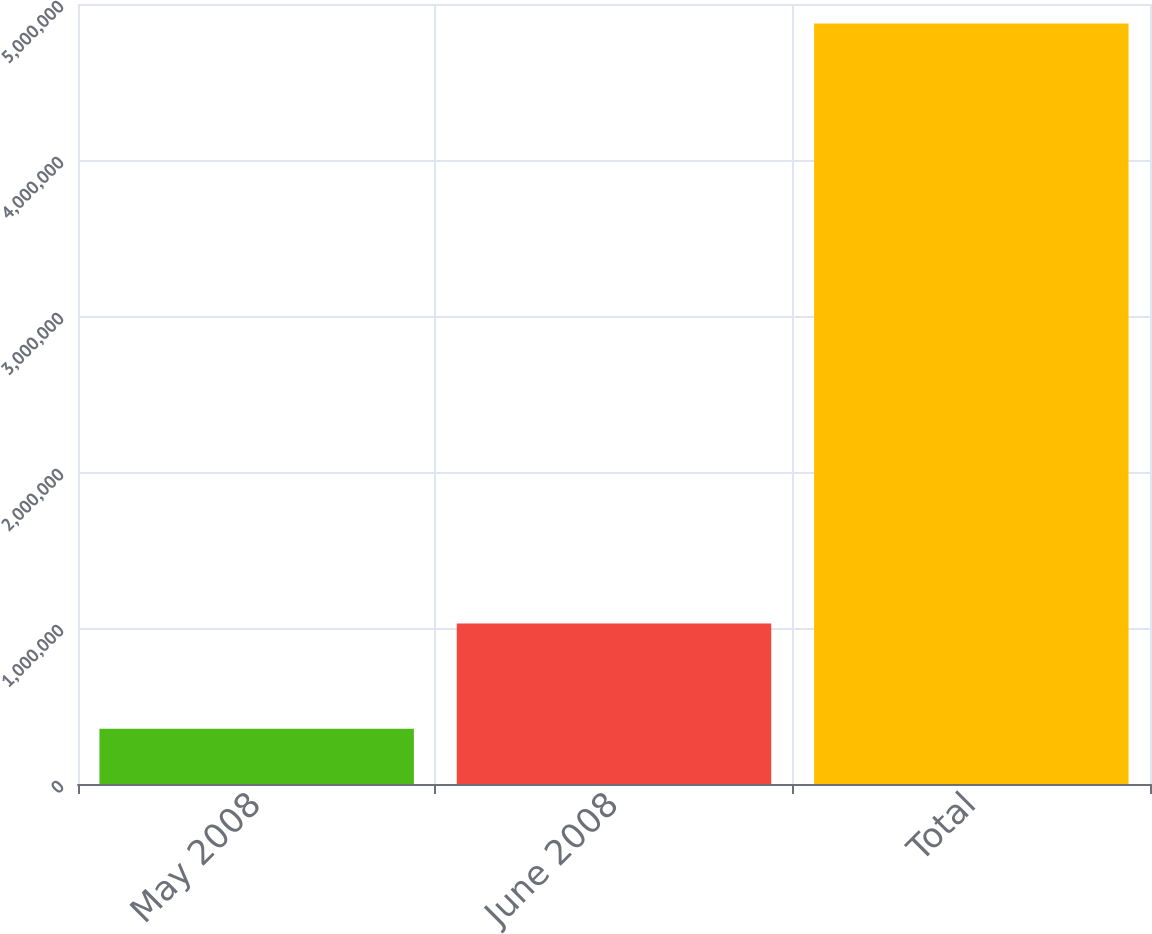Convert chart. <chart><loc_0><loc_0><loc_500><loc_500><bar_chart><fcel>May 2008<fcel>June 2008<fcel>Total<nl><fcel>354600<fcel>1.0285e+06<fcel>4.87562e+06<nl></chart> 